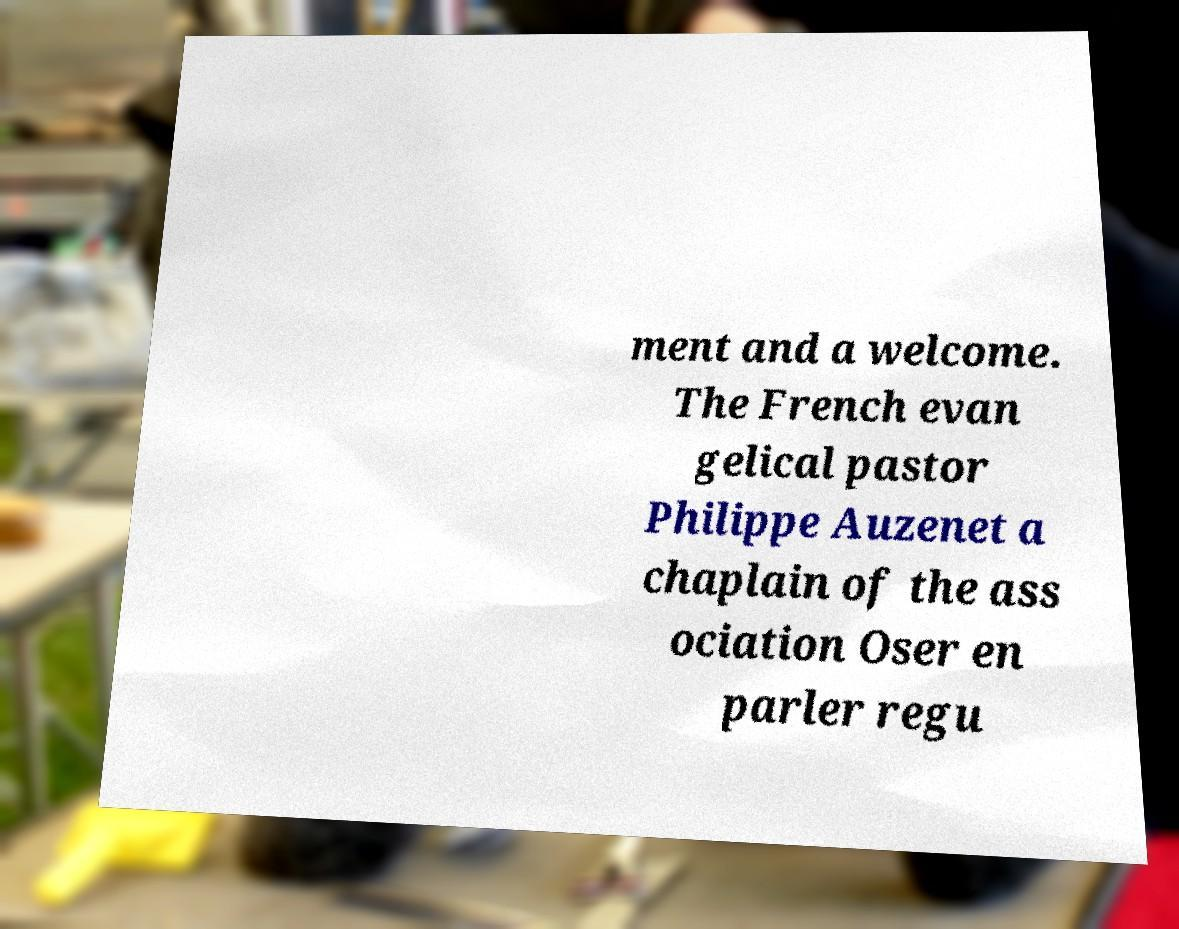What messages or text are displayed in this image? I need them in a readable, typed format. ment and a welcome. The French evan gelical pastor Philippe Auzenet a chaplain of the ass ociation Oser en parler regu 